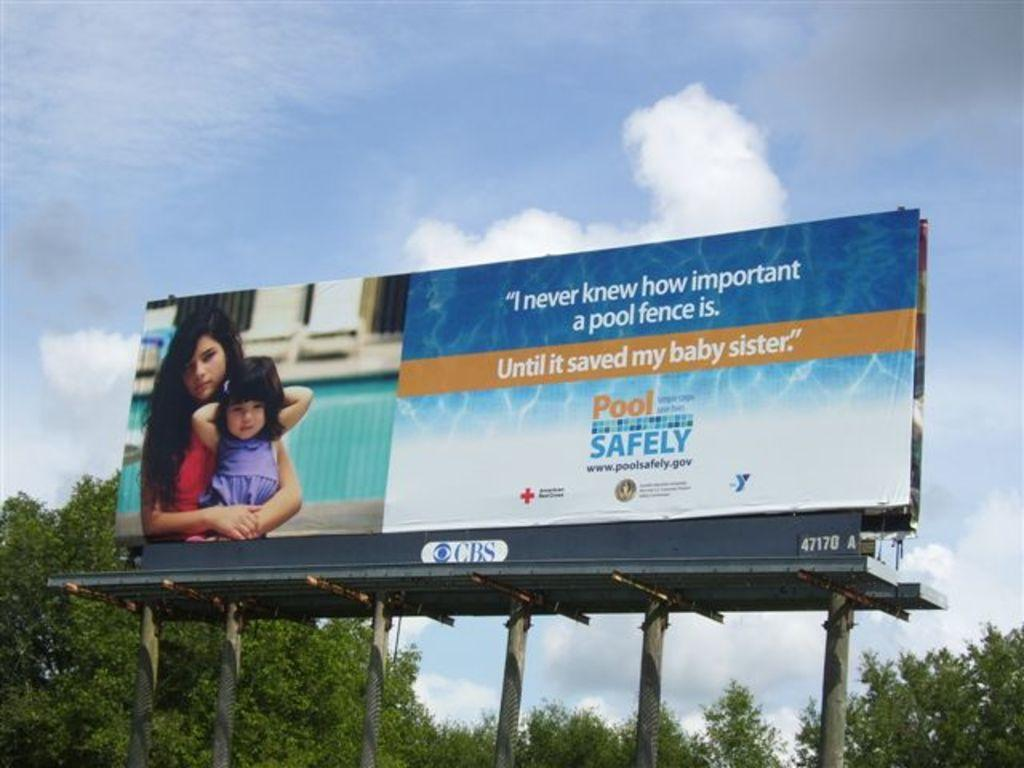Provide a one-sentence caption for the provided image. A billboard for Pool Safety with a CBS logo underneath it. 